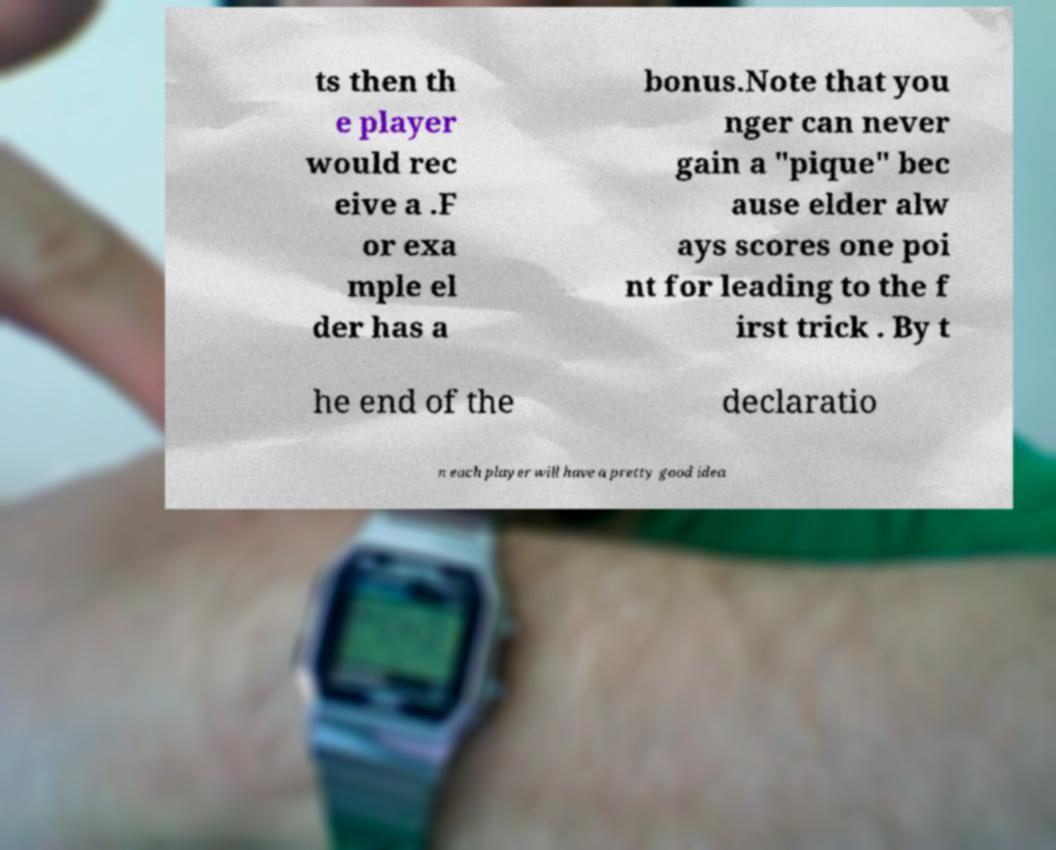For documentation purposes, I need the text within this image transcribed. Could you provide that? ts then th e player would rec eive a .F or exa mple el der has a bonus.Note that you nger can never gain a "pique" bec ause elder alw ays scores one poi nt for leading to the f irst trick . By t he end of the declaratio n each player will have a pretty good idea 